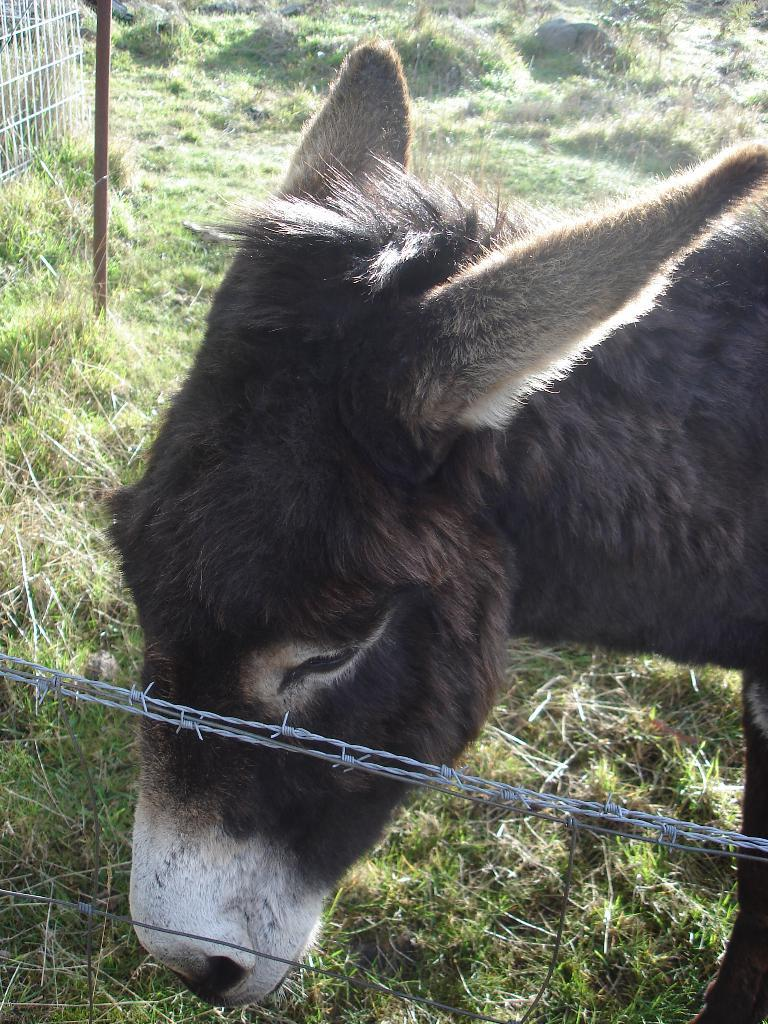What type of animal can be seen in the image? There is an animal in the image, but its specific type cannot be determined from the provided facts. What is the purpose of the fencing wires in the image? The purpose of the fencing wires in the image is not clear from the provided facts. What type of vegetation is visible in the background of the image? There is grass in the background of the image. What structures are present on the left side top of the image? There is a pole and grills on the left side top of the image. What is the opinion of the animal about the wrench in the image? There is no wrench present in the image, and therefore the animal's opinion about it cannot be determined. How many feet does the animal have in the image? The number of feet the animal has cannot be determined from the provided facts, as the specific type of animal is not mentioned. 